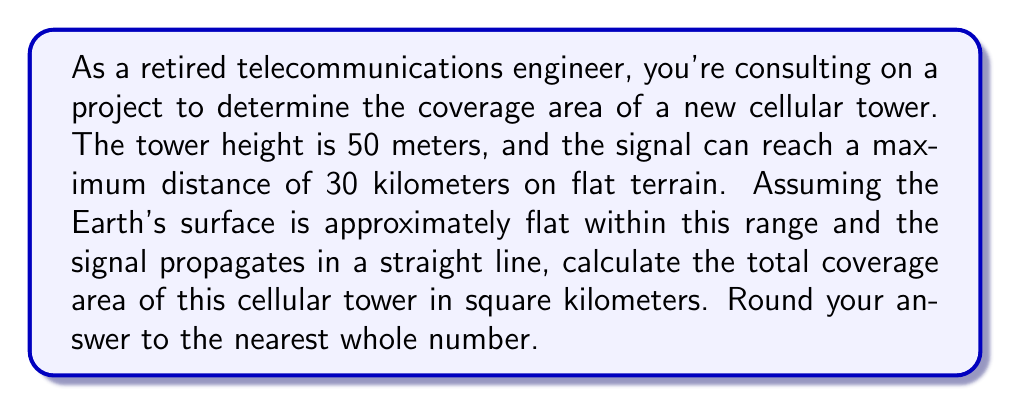Can you solve this math problem? To solve this problem, we need to consider the geometry of the situation. The coverage area of a cellular tower can be approximated as a circular area on the ground.

1. Visualize the problem:
   [asy]
   import geometry;
   
   size(200);
   
   pair O = (0,0);
   pair A = (6,0);
   pair B = (6,1);
   
   draw(O--A--B--cycle);
   
   label("Earth's surface", (3,0), S);
   label("Tower", (0,0), W);
   label("50 m", (0,0.5), W);
   label("30 km", (3,-0.2), S);
   
   draw(arc(O,6,0,9.46), dashed);
   label("Coverage area", (5,2), NE);
   [/asy]

2. In this case, the radius of the coverage area is the maximum distance the signal can reach, which is 30 km.

3. The formula for the area of a circle is:

   $$A = \pi r^2$$

   Where:
   $A$ is the area
   $\pi$ is approximately 3.14159
   $r$ is the radius

4. Substituting the values:

   $$A = \pi \cdot (30 \text{ km})^2$$

5. Calculate:

   $$A = 3.14159 \cdot 900 \text{ km}^2$$
   $$A = 2,827.431 \text{ km}^2$$

6. Rounding to the nearest whole number:

   $$A \approx 2,827 \text{ km}^2$$

Note: The tower height of 50 meters is not directly used in this calculation because we're assuming flat terrain and that the signal propagates in a straight line. In real-world scenarios, the tower height would affect the maximum distance the signal can reach, but for this simplified model, we use the given maximum distance directly.
Answer: The total coverage area of the cellular tower is approximately 2,827 km². 